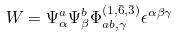<formula> <loc_0><loc_0><loc_500><loc_500>W = \Psi ^ { a } _ { \alpha } \Psi ^ { b } _ { \beta } \Phi ^ { ( { 1 } , { \bar { 6 } } , { \bar { 3 } } ) } _ { a b , \gamma } \epsilon ^ { \alpha \beta \gamma }</formula> 